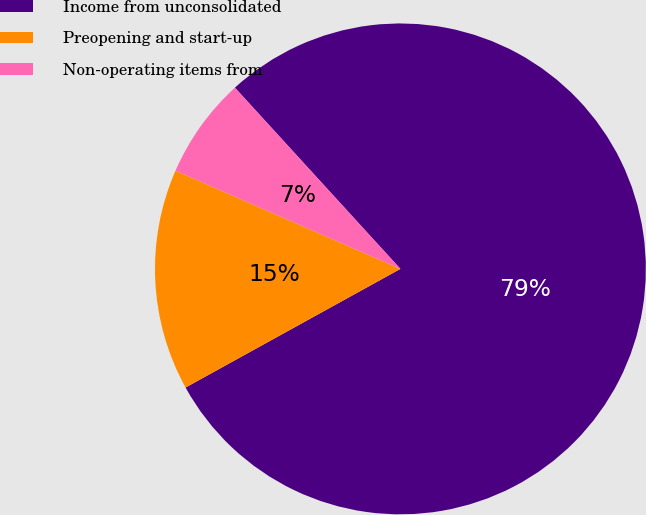<chart> <loc_0><loc_0><loc_500><loc_500><pie_chart><fcel>Income from unconsolidated<fcel>Preopening and start-up<fcel>Non-operating items from<nl><fcel>78.75%<fcel>14.58%<fcel>6.67%<nl></chart> 